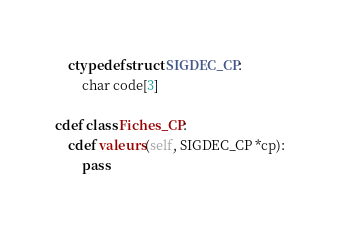<code> <loc_0><loc_0><loc_500><loc_500><_Cython_>    ctypedef struct SIGDEC_CP:
        char code[3]

cdef class Fiches_CP:
    cdef valeurs(self, SIGDEC_CP *cp):
        pass
</code> 